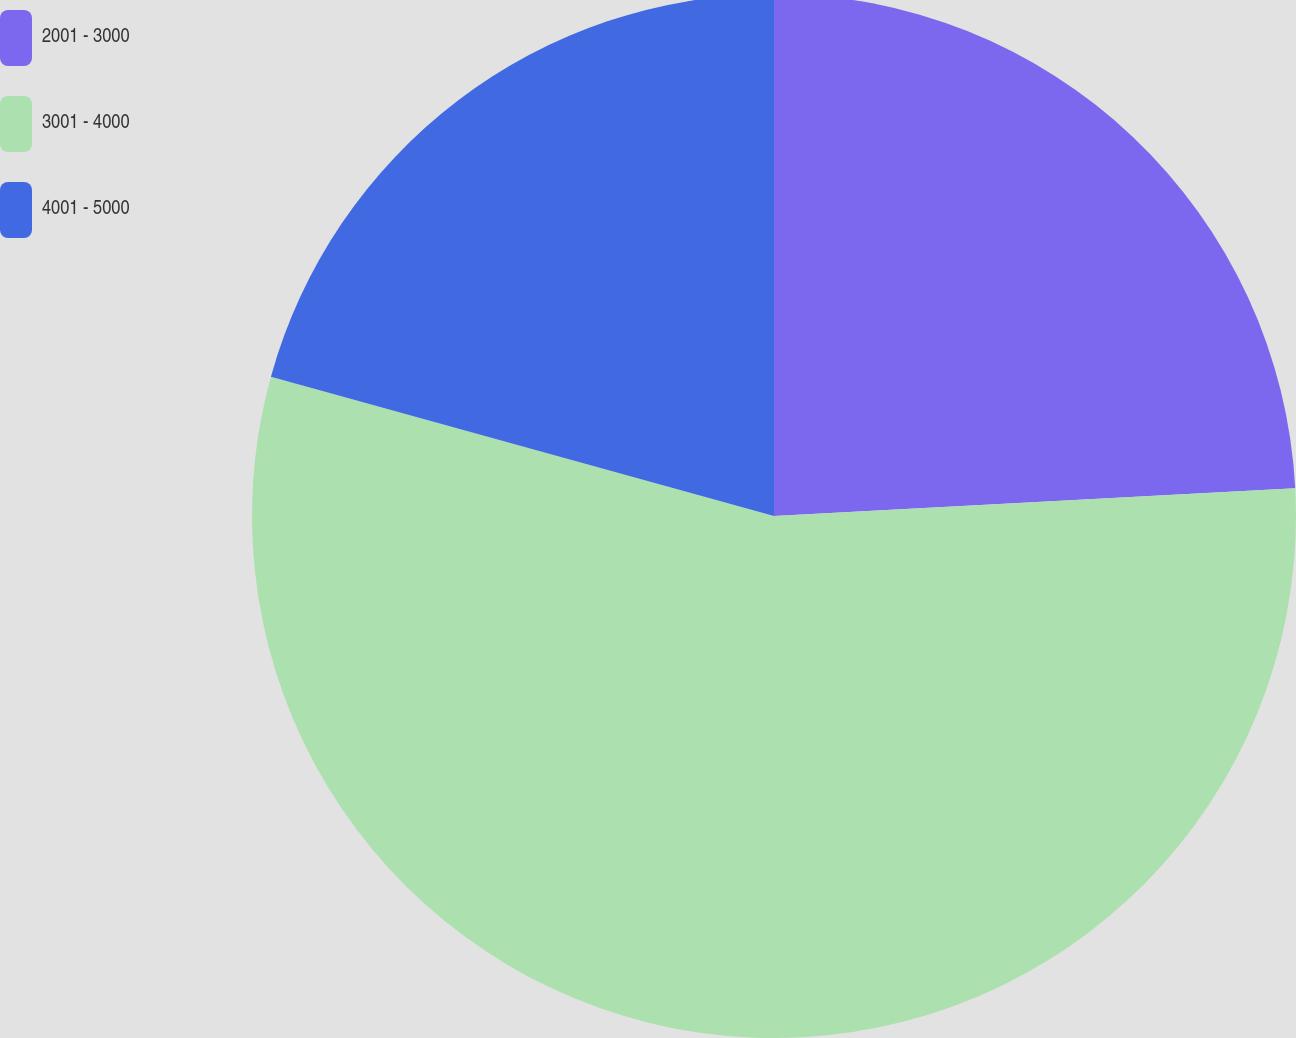Convert chart to OTSL. <chart><loc_0><loc_0><loc_500><loc_500><pie_chart><fcel>2001 - 3000<fcel>3001 - 4000<fcel>4001 - 5000<nl><fcel>24.15%<fcel>55.15%<fcel>20.7%<nl></chart> 